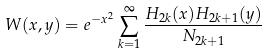Convert formula to latex. <formula><loc_0><loc_0><loc_500><loc_500>W ( x , y ) = e ^ { - x ^ { 2 } } \sum _ { k = 1 } ^ { \infty } \frac { H _ { 2 k } ( x ) H _ { 2 k + 1 } ( y ) } { N _ { 2 k + 1 } }</formula> 